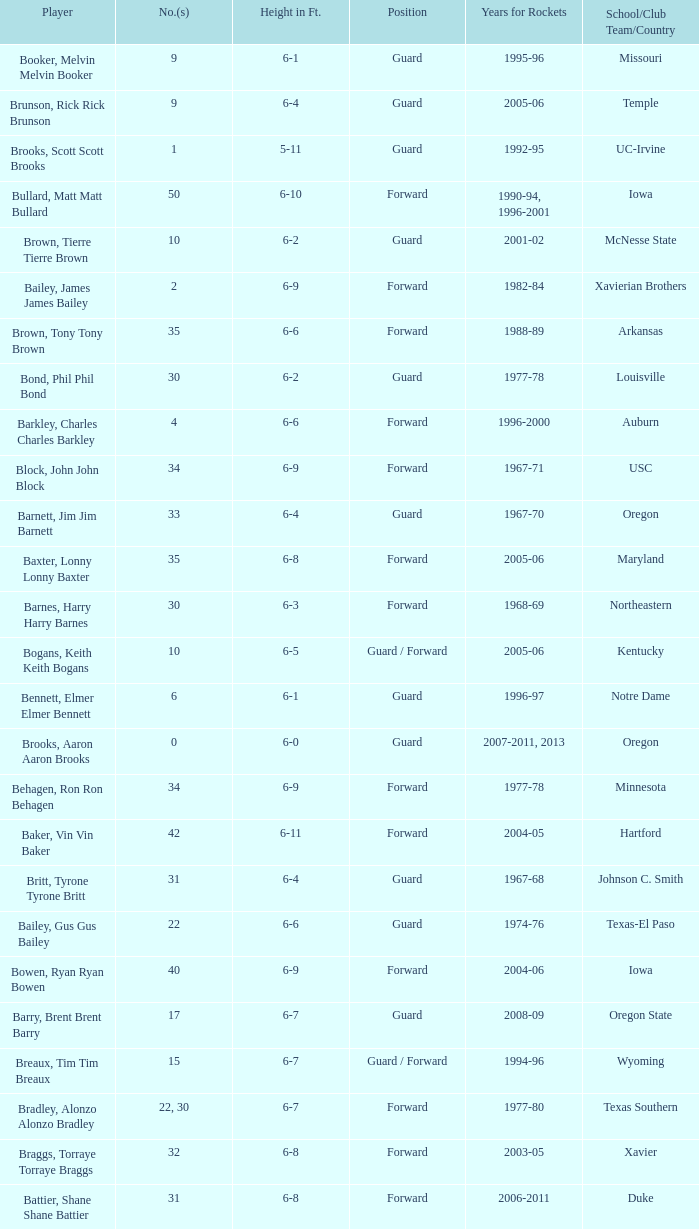What years did the player from LaSalle play for the Rockets? 1982-83. 